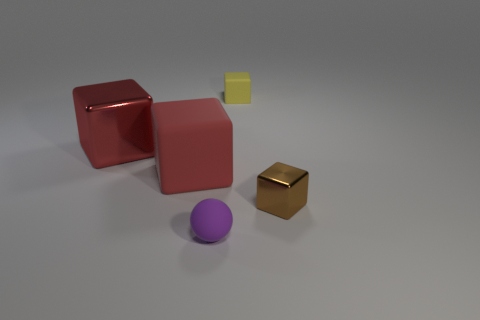Subtract all small yellow cubes. How many cubes are left? 3 Add 3 large cyan things. How many large cyan things exist? 3 Add 1 matte cylinders. How many objects exist? 6 Subtract all yellow cubes. How many cubes are left? 3 Subtract 1 red blocks. How many objects are left? 4 Subtract all spheres. How many objects are left? 4 Subtract 1 balls. How many balls are left? 0 Subtract all red balls. Subtract all cyan cubes. How many balls are left? 1 Subtract all green balls. How many red blocks are left? 2 Subtract all large green spheres. Subtract all brown things. How many objects are left? 4 